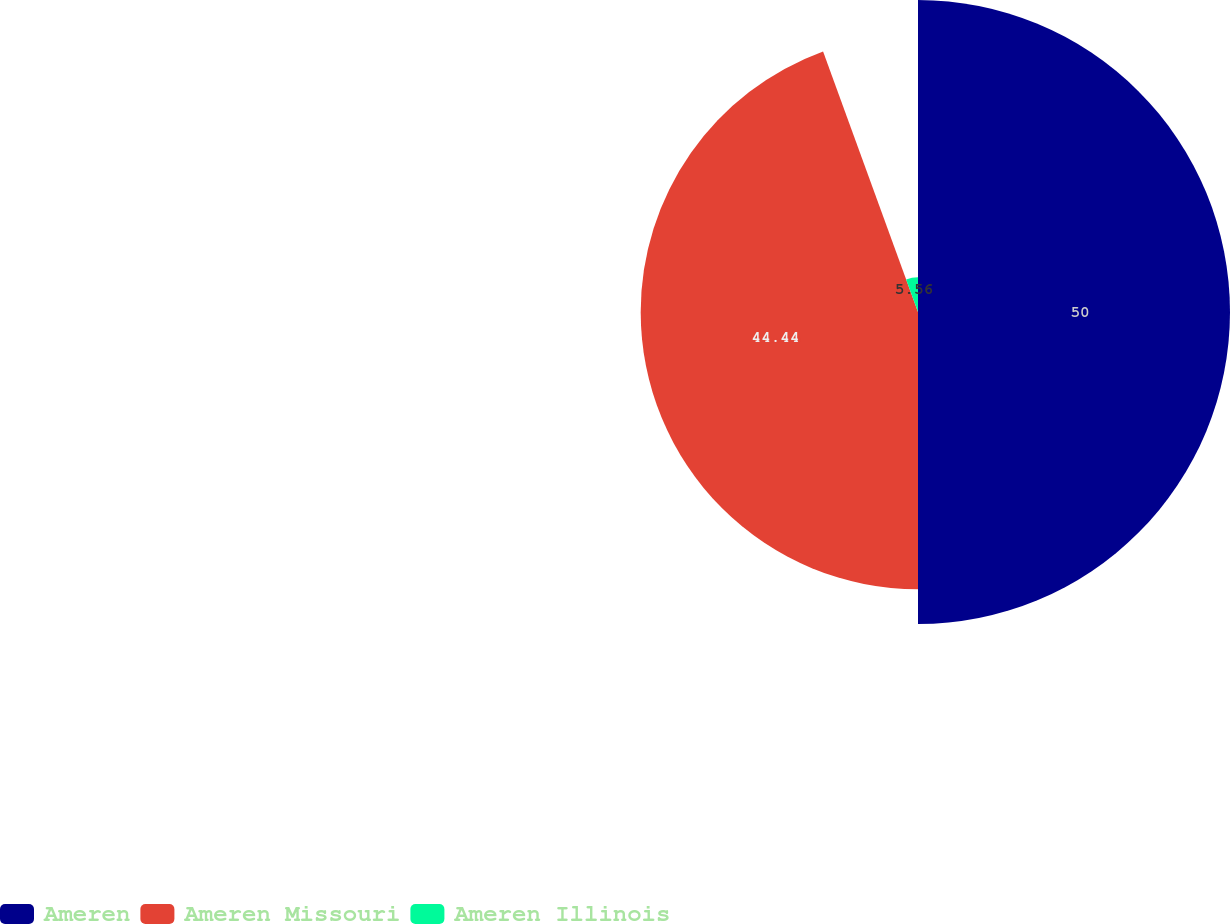Convert chart. <chart><loc_0><loc_0><loc_500><loc_500><pie_chart><fcel>Ameren<fcel>Ameren Missouri<fcel>Ameren Illinois<nl><fcel>50.0%<fcel>44.44%<fcel>5.56%<nl></chart> 